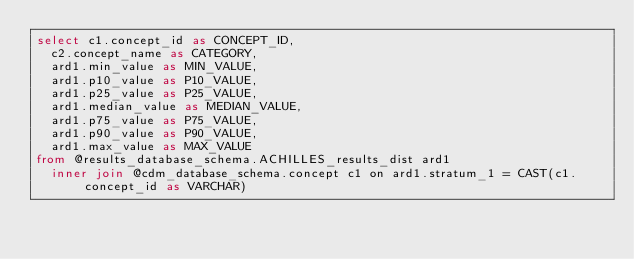Convert code to text. <code><loc_0><loc_0><loc_500><loc_500><_SQL_>select c1.concept_id as CONCEPT_ID,
	c2.concept_name as CATEGORY,
	ard1.min_value as MIN_VALUE,
	ard1.p10_value as P10_VALUE,
	ard1.p25_value as P25_VALUE,
	ard1.median_value as MEDIAN_VALUE,
	ard1.p75_value as P75_VALUE,
	ard1.p90_value as P90_VALUE,
	ard1.max_value as MAX_VALUE
from @results_database_schema.ACHILLES_results_dist ard1
	inner join @cdm_database_schema.concept c1 on ard1.stratum_1 = CAST(c1.concept_id as VARCHAR)</code> 